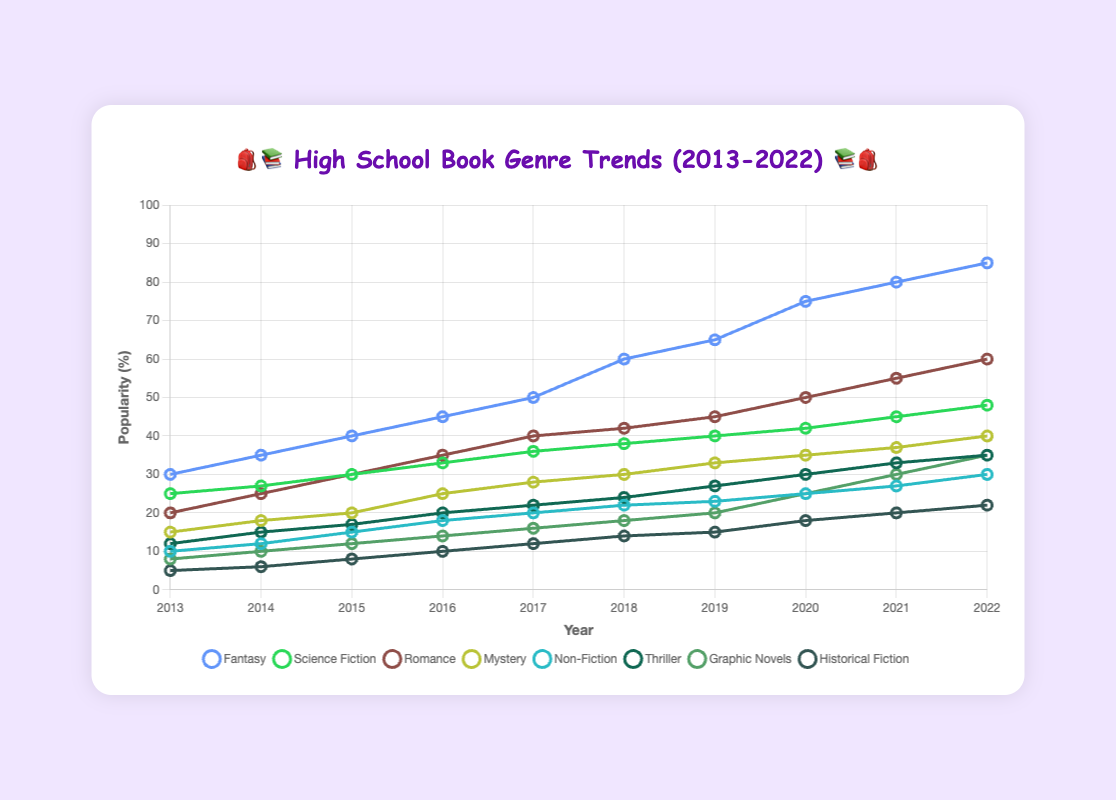Which genre had the highest increase in popularity over the decade? To determine the genre with the highest increase, calculate the difference between 2022 and 2013 for each genre: Fantasy (85-30=55), Science Fiction (48-25=23), Romance (60-20=40), Mystery (40-15=25), Non-Fiction (30-10=20), Thriller (35-12=23), Graphic Novels (35-8=27), Historical Fiction (22-5=17). Fantasy had the highest increase.
Answer: Fantasy In which year did Romance and Thriller genres have equal popularity? Look for the year in which the percentage values for Romance and Thriller genres match. In the year 2019, both genres were at 45%.
Answer: 2019 By how much did the popularity of Mystery increase from 2013 to 2017? Calculate the difference in Mystery genre's popularity from 2013 to 2017: 28 (2017) - 15 (2013) = 13.
Answer: 13 Which genre showed a steady yet small increase in popularity over the decade? Check for a genre with consistent but small increments annually. Science Fiction shows incremental increases each year.
Answer: Science Fiction What is the approximate average popularity of Historical Fiction in the years 2019 and 2022? Sum the popularity of Historical Fiction in 2019 and 2022 and divide by 2: (15+22)/2 = 18.5.
Answer: 18.5 Which two genres had almost the same popularity in the year 2014? Compare the values for each genre in 2014; looking closely at 35 (Fantasy) and 36 (Science Fiction), they are closest.
Answer: Fantasy and Science Fiction What was the total popularity percentage of Fantasy and Non-Fiction in 2016? Add the values for Fantasy and Non-Fiction in 2016: 45 (Fantasy) + 18 (Non-Fiction) = 63.
Answer: 63 Between 2013 and 2022, which genre showed a higher overall popularity trend: Graphic Novels or Thriller? Compare the endpoint and growth of each genre over the decade: Graphic Novels (35-8=27), Thriller (35-12=23), so Graphic Novels had a higher trend.
Answer: Graphic Novels In which year did Fantasy overtake Science Fiction in popularity? Identify the first year Fantasy's value is higher than Science Fiction: in 2014, Fantasy is 35 and Science Fiction is 27. So, Fantasy overtakes in 2014.
Answer: 2014 